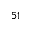Convert formula to latex. <formula><loc_0><loc_0><loc_500><loc_500>^ { 5 1 }</formula> 